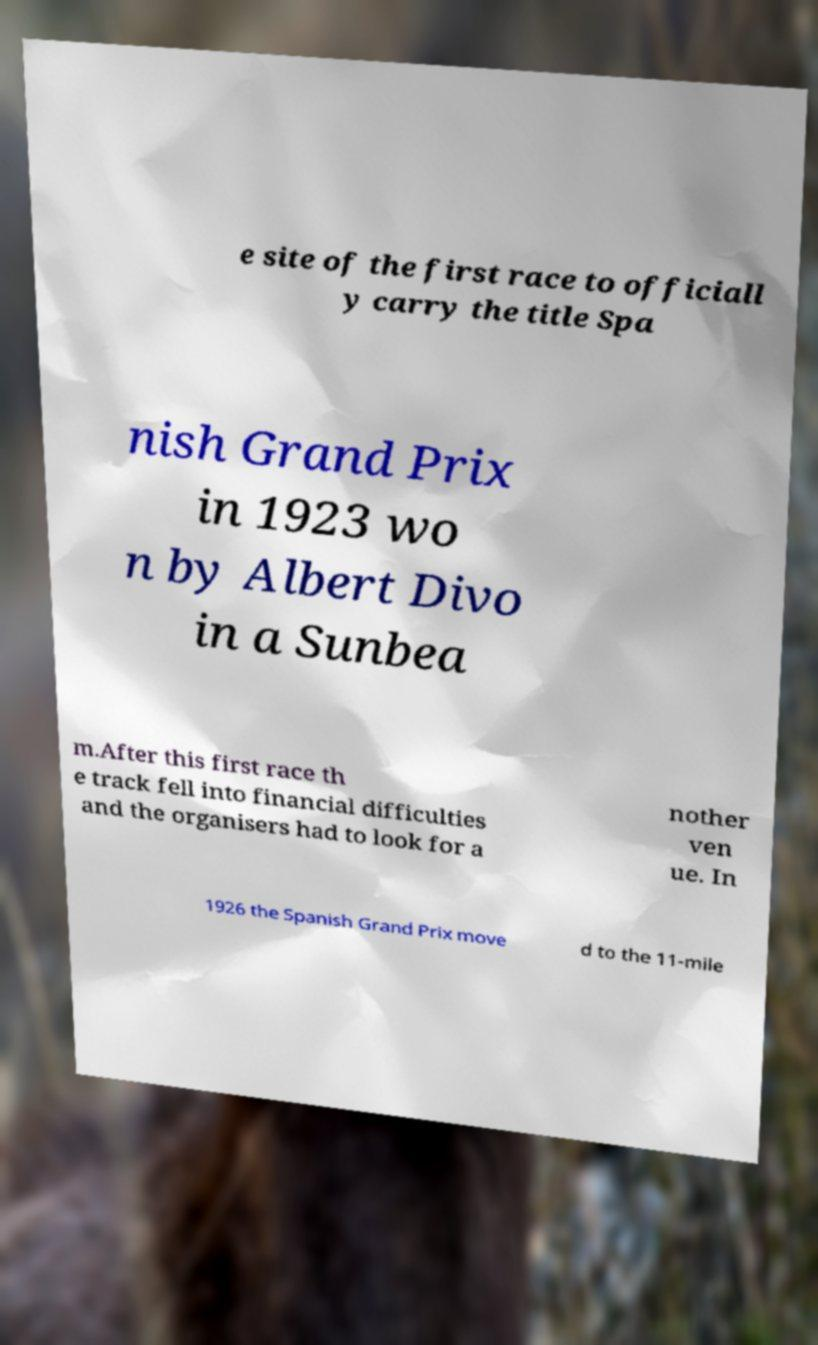I need the written content from this picture converted into text. Can you do that? e site of the first race to officiall y carry the title Spa nish Grand Prix in 1923 wo n by Albert Divo in a Sunbea m.After this first race th e track fell into financial difficulties and the organisers had to look for a nother ven ue. In 1926 the Spanish Grand Prix move d to the 11-mile 